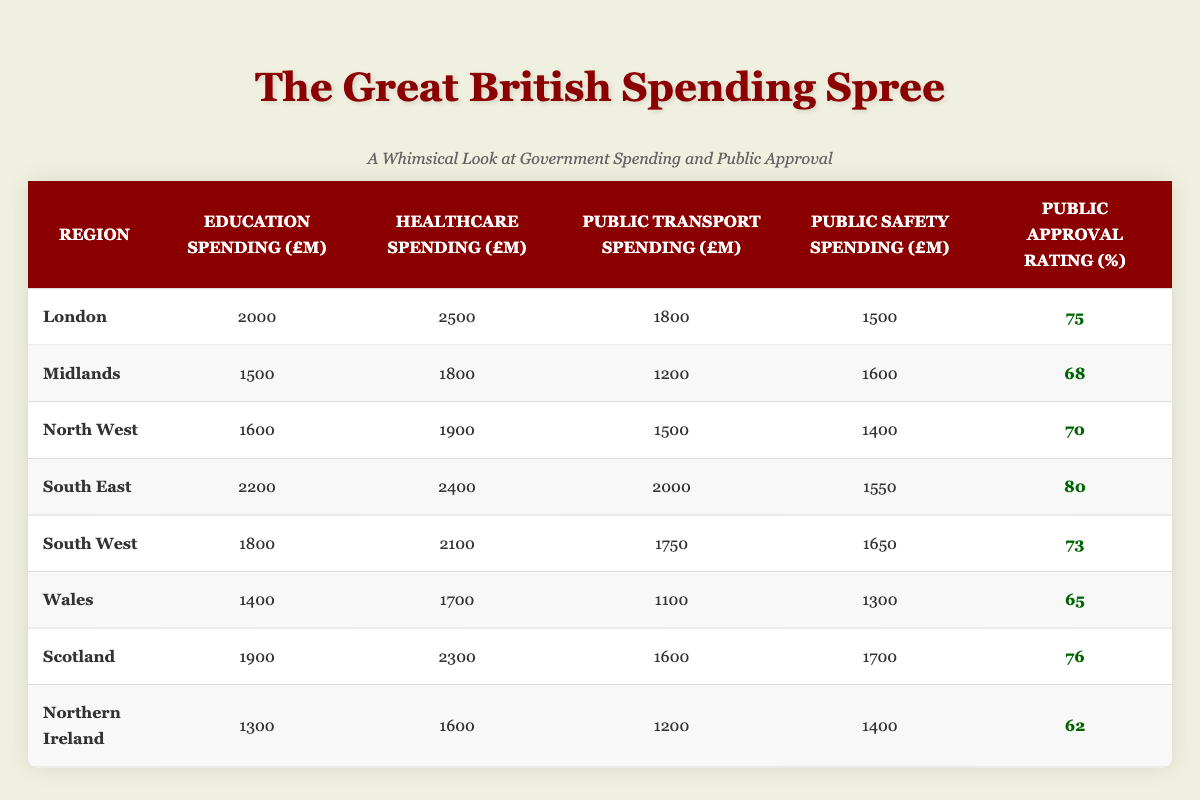What is the public approval rating for London? In the table, I can find the row for London, and in the column for Public Approval Rating, the value is 75.
Answer: 75 Which region has the highest education spending? Looking through the Education Spending column, I see that the South East has the highest value of 2200 million.
Answer: South East Is the public approval rating for Wales above 65? In the table, the public approval rating for Wales is 65. Since the question asks if it is above that number, the answer is no.
Answer: No What is the average public approval rating across all regions? I will add the public approval ratings together: (75 + 68 + 70 + 80 + 73 + 65 + 76 + 62) = 599. There are 8 regions, so I divide 599 by 8, which gives me an average of 74.875.
Answer: 74.875 What is the total healthcare spending for the regions in the South (South East and South West)? For the South East, the healthcare spending is 2400 million and for the South West, it is 2100 million. Adding these values together gives 2400 + 2100 = 4500 million.
Answer: 4500 million Does education spending correlate positively with public approval ratings in this table? To determine this, I will look at regions with higher education spending and their approval ratings. The South East has high spending and a high approval rating, but other regions vary. It appears there might be a weak correlation.
Answer: Yes, weak correlation Which region spends the least on public safety? In the Public Safety Spending column, I see that Northern Ireland spends the least with 1400 million.
Answer: Northern Ireland What is the difference in public transport spending between the highest and lowest regions? The highest public transport spending is from the South East at 2000 million, and the lowest is from Wales at 1100 million. The difference is 2000 - 1100, which equals 900 million.
Answer: 900 million Which regions have a public approval rating of over 75? The regions with a public approval rating over 75 are South East (80) and Scotland (76).
Answer: South East, Scotland 